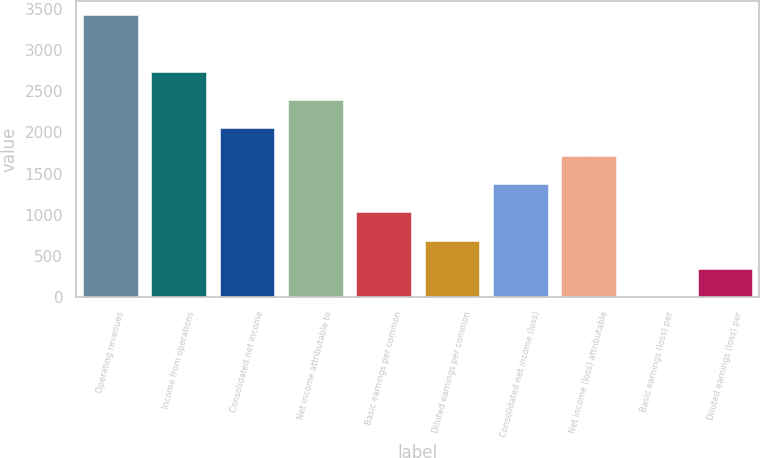<chart> <loc_0><loc_0><loc_500><loc_500><bar_chart><fcel>Operating revenues<fcel>Income from operations<fcel>Consolidated net income<fcel>Net income attributable to<fcel>Basic earnings per common<fcel>Diluted earnings per common<fcel>Consolidated net income (loss)<fcel>Net income (loss) attributable<fcel>Basic earnings (loss) per<fcel>Diluted earnings (loss) per<nl><fcel>3425<fcel>2740.12<fcel>2055.24<fcel>2397.68<fcel>1027.92<fcel>685.48<fcel>1370.36<fcel>1712.8<fcel>0.6<fcel>343.04<nl></chart> 